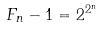Convert formula to latex. <formula><loc_0><loc_0><loc_500><loc_500>F _ { n } - 1 = 2 ^ { 2 ^ { n } }</formula> 